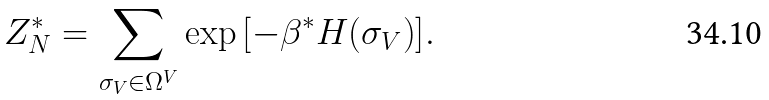Convert formula to latex. <formula><loc_0><loc_0><loc_500><loc_500>Z _ { N } ^ { * } = \sum _ { \sigma _ { V } \in \Omega ^ { V } } \exp { \left [ - \beta ^ { * } H { \left ( \sigma _ { V } \right ) } \right ] } .</formula> 